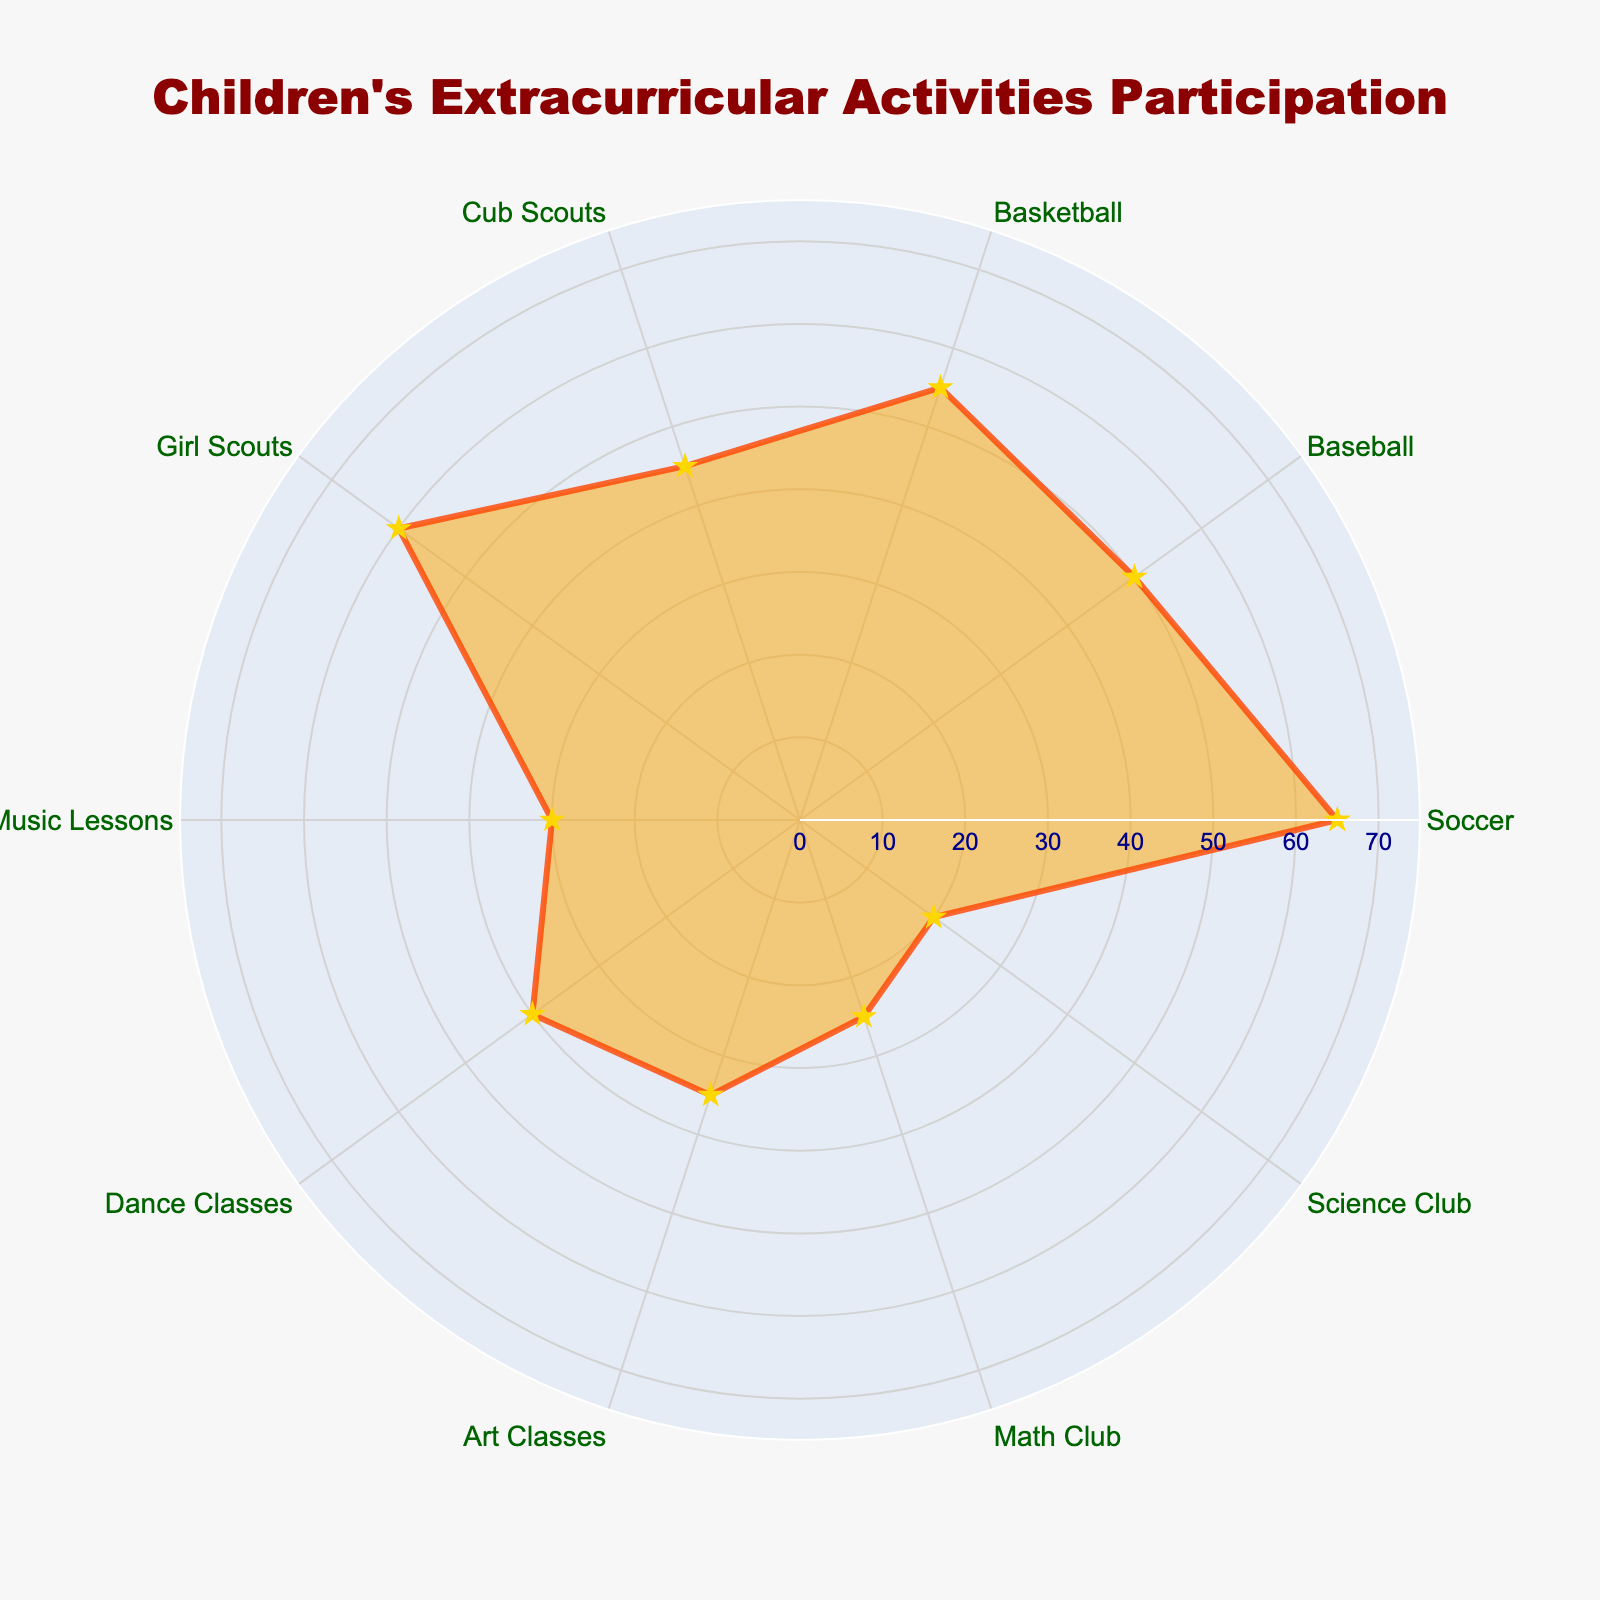what activity has the highest participation rate? The radar chart displays several activities with their participation rates. By viewing the chart, we can identify the highest value, which corresponds to the activity with 65%.
Answer: Soccer what color is used to fill the chart area? The radar chart is filled with a light shading that spans the area enclosed by the participation rates. The specific fill color is light orange.
Answer: light orange How many activities have a participation rate above 50%? By inspecting the radar chart, we can count the activities with values above the 50% radial line. Soccer (65%), Basketball (55%), Girl Scouts (60%), and Baseball (50%).
Answer: 4 Which activity has the lowest participation rate, and what is it? Looking at the radar chart, the lowest point on the scale represents the activity with the least participation. This activity has a value of 20%.
Answer: Science Club What is the title of the radar chart? The chart title is prominent and typically positioned near the top of the radar chart.
Answer: Children's Extracurricular Activities Participation What is the average participation rate of Soccer and Cub Scouts? To find the average participation rate, we add the values of Soccer (65%) and Cub Scouts (45%) and then divide by 2. Calculation: (65 + 45) / 2 = 55
Answer: 55 Compare the participation rates of Music Lessons and Art Classes. Which is higher and by how much? From the chart, identify the values for Music Lessons (30%) and Art Classes (35%). Subtract Music Lessons from Art Classes to find the difference. Calculation: 35 - 30 = 5
Answer: Art Classes, 5% What shape is marked at each data point on the radar chart? By observing the data points on the radar chart, we can identify the specific marker shape used for each activity.
Answer: star How many extracurricular activities are displayed in the radar chart? The radar chart includes labeled points around the perimeter indicating different activities. Counting these gives the total number of activities represented.
Answer: 10 What is the total participation rate of all activities combined? We need to sum the participation rates for each activity: 65 (Soccer) + 50 (Baseball) + 55 (Basketball) + 45 (Cub Scouts) + 60 (Girl Scouts) + 30 (Music Lessons) + 40 (Dance Classes) + 35 (Art Classes) + 25 (Math Club) + 20 (Science Club). Calculation: 65 + 50 + 55 + 45 + 60 + 30 + 40 + 35 + 25 + 20 = 425
Answer: 425 